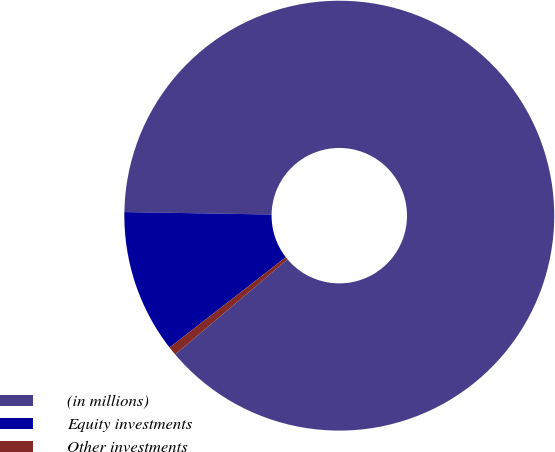<chart> <loc_0><loc_0><loc_500><loc_500><pie_chart><fcel>(in millions)<fcel>Equity investments<fcel>Other investments<nl><fcel>88.56%<fcel>10.78%<fcel>0.66%<nl></chart> 